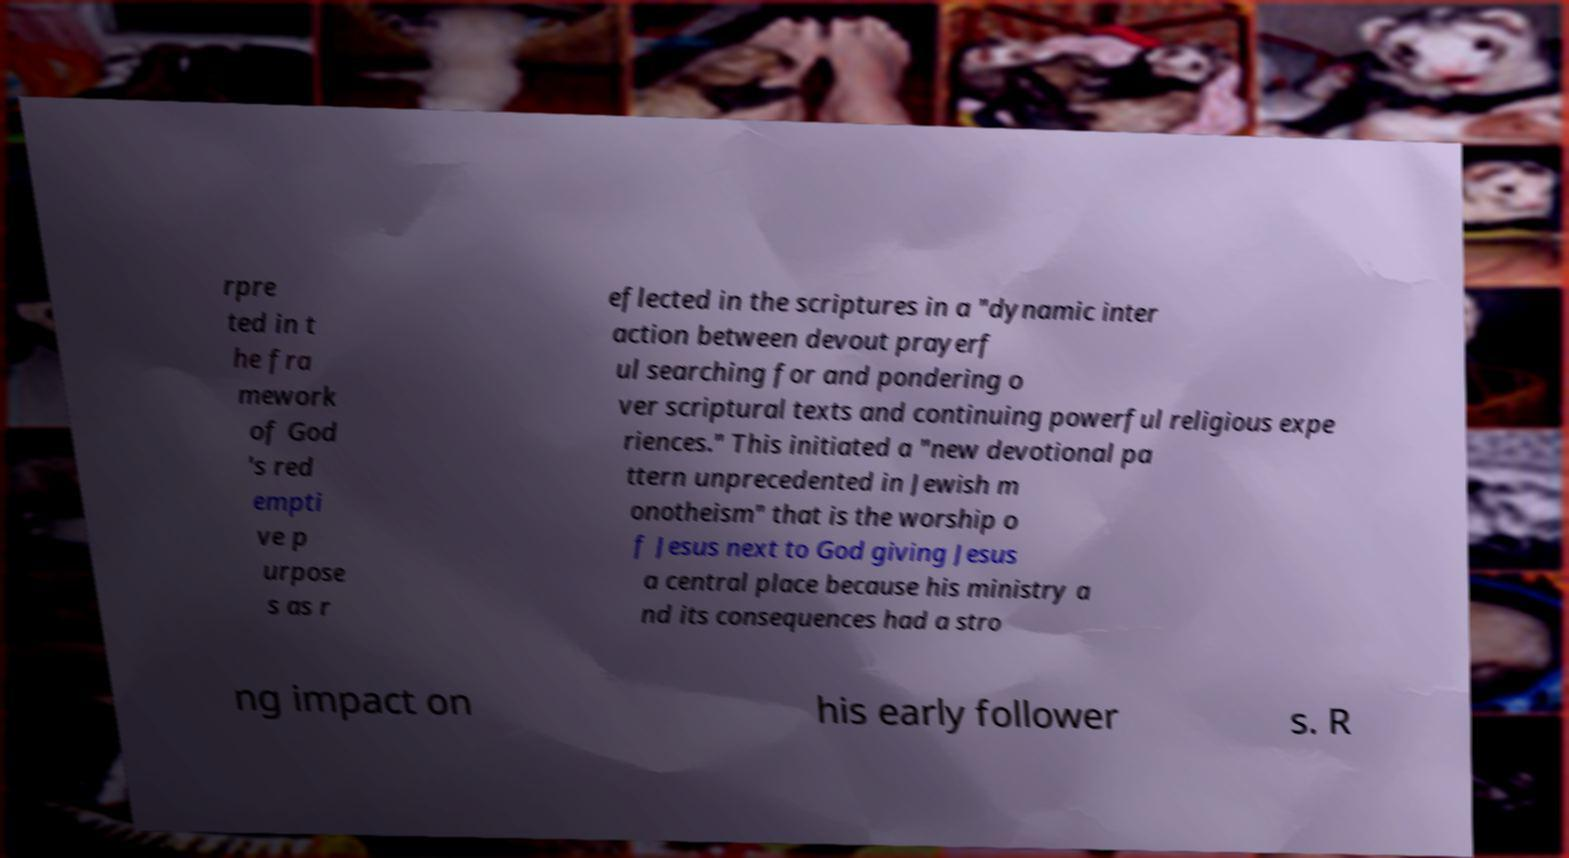What messages or text are displayed in this image? I need them in a readable, typed format. rpre ted in t he fra mework of God 's red empti ve p urpose s as r eflected in the scriptures in a "dynamic inter action between devout prayerf ul searching for and pondering o ver scriptural texts and continuing powerful religious expe riences." This initiated a "new devotional pa ttern unprecedented in Jewish m onotheism" that is the worship o f Jesus next to God giving Jesus a central place because his ministry a nd its consequences had a stro ng impact on his early follower s. R 